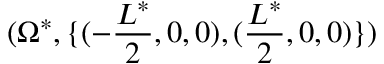Convert formula to latex. <formula><loc_0><loc_0><loc_500><loc_500>( \Omega ^ { \ast } , \{ ( - \frac { L ^ { \ast } } { 2 } , 0 , 0 ) , ( \frac { L ^ { \ast } } { 2 } , 0 , 0 ) \} )</formula> 